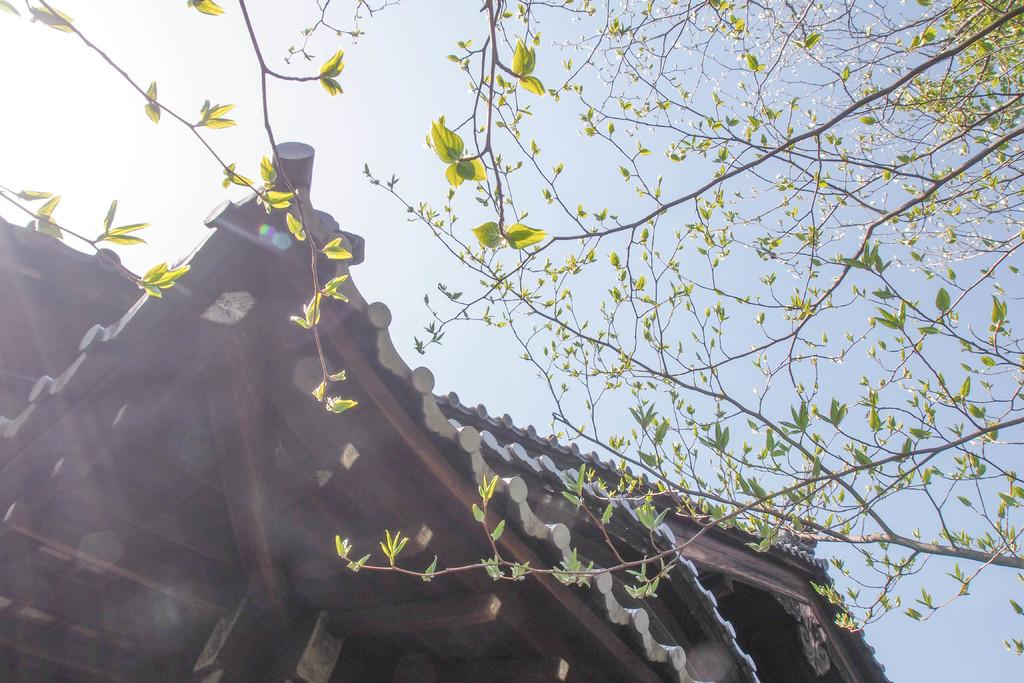What type of structure is present in the image? There is a house in the image. What natural element can be seen in the image? There are branches of a tree in the image. What is visible in the background of the image? The sky is visible in the image. How many ladybugs are sitting on the calendar in the image? There is no calendar or ladybugs present in the image. 